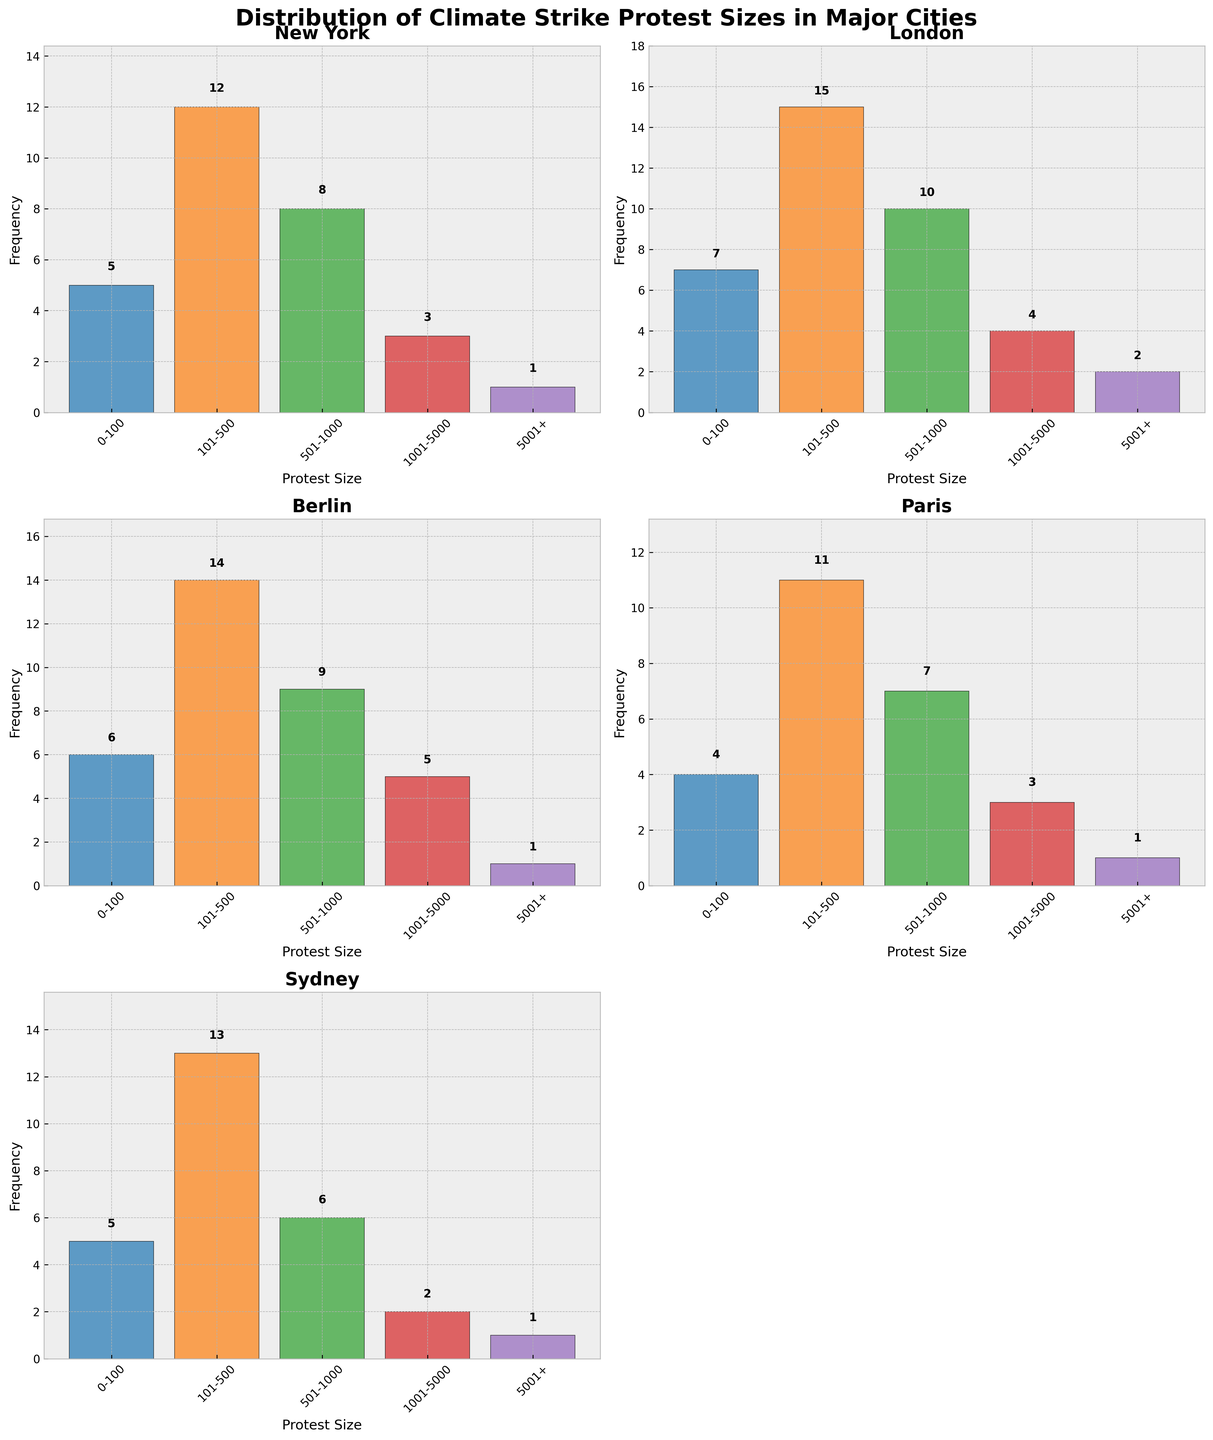What is the title of the plot? The title of the plot is located at the top of the figure and clearly states, "Distribution of Climate Strike Protest Sizes in Major Cities."
Answer: Distribution of Climate Strike Protest Sizes in Major Cities Which city has the highest frequency of protests in the 101-500 size range? By comparing the heights of the bars in the 101-500 size range across each subplot, London shows the highest frequency with a count of 15.
Answer: London How many cities are included in the figure? There are multiple subplots in the figure, each representing a city: New York, London, Berlin, Paris, and Sydney. Counting these subplots gives a total of 5 cities.
Answer: 5 In which city do we see the fewest protests in the 501-1000 size range? Comparing the bars representing the 501-1000 size range across the subplots, Sydney has the fewest protests with a frequency of 6.
Answer: Sydney What is the combined frequency of protests larger than 5000 in all cities? Summing the frequencies for the 5001+ size range from each city: New York (1) + London (2) + Berlin (1) + Paris (1) + Sydney (1) = 6.
Answer: 6 Which city has the highest frequency of protests in the 0-100 size range? By examining the heights of the bars in the 0-100 size range across each subplot, London has the highest frequency with a count of 7.
Answer: London Compare the frequency of the largest protest size category (5001+) between New York and Paris. Which has a higher frequency? In the 5001+ size range, New York has a frequency of 1 and Paris also has a frequency of 1. Therefore, both cities have the same frequency in this category.
Answer: Same frequency What is the average frequency of protests in the 1001-5000 range across all cities? Adding up the frequencies in the 1001-5000 size range for all cities: New York (3) + London (4) + Berlin (5) + Paris (3) + Sydney (2) = 17. Then, dividing by the number of cities: 17/5 = 3.4.
Answer: 3.4 